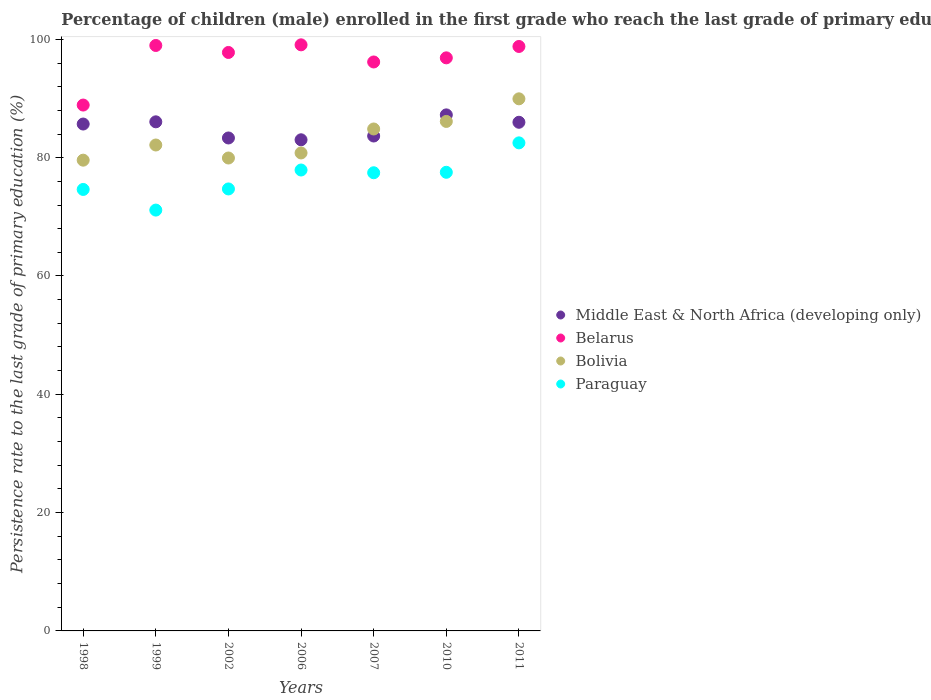How many different coloured dotlines are there?
Ensure brevity in your answer.  4. Is the number of dotlines equal to the number of legend labels?
Your response must be concise. Yes. What is the persistence rate of children in Bolivia in 2002?
Offer a very short reply. 79.95. Across all years, what is the maximum persistence rate of children in Middle East & North Africa (developing only)?
Your answer should be very brief. 87.24. Across all years, what is the minimum persistence rate of children in Paraguay?
Keep it short and to the point. 71.14. In which year was the persistence rate of children in Belarus minimum?
Offer a terse response. 1998. What is the total persistence rate of children in Paraguay in the graph?
Provide a short and direct response. 535.9. What is the difference between the persistence rate of children in Belarus in 1998 and that in 1999?
Give a very brief answer. -10.07. What is the difference between the persistence rate of children in Middle East & North Africa (developing only) in 1998 and the persistence rate of children in Paraguay in 2010?
Your answer should be compact. 8.16. What is the average persistence rate of children in Belarus per year?
Ensure brevity in your answer.  96.66. In the year 2010, what is the difference between the persistence rate of children in Paraguay and persistence rate of children in Bolivia?
Offer a terse response. -8.6. In how many years, is the persistence rate of children in Belarus greater than 8 %?
Offer a terse response. 7. What is the ratio of the persistence rate of children in Middle East & North Africa (developing only) in 2010 to that in 2011?
Your response must be concise. 1.01. Is the persistence rate of children in Bolivia in 1998 less than that in 2010?
Provide a short and direct response. Yes. Is the difference between the persistence rate of children in Paraguay in 2002 and 2010 greater than the difference between the persistence rate of children in Bolivia in 2002 and 2010?
Keep it short and to the point. Yes. What is the difference between the highest and the second highest persistence rate of children in Paraguay?
Provide a short and direct response. 4.59. What is the difference between the highest and the lowest persistence rate of children in Bolivia?
Give a very brief answer. 10.37. Is it the case that in every year, the sum of the persistence rate of children in Bolivia and persistence rate of children in Belarus  is greater than the persistence rate of children in Paraguay?
Offer a very short reply. Yes. What is the difference between two consecutive major ticks on the Y-axis?
Ensure brevity in your answer.  20. Are the values on the major ticks of Y-axis written in scientific E-notation?
Your answer should be compact. No. Does the graph contain any zero values?
Offer a very short reply. No. Where does the legend appear in the graph?
Make the answer very short. Center right. What is the title of the graph?
Ensure brevity in your answer.  Percentage of children (male) enrolled in the first grade who reach the last grade of primary education. What is the label or title of the Y-axis?
Offer a terse response. Persistence rate to the last grade of primary education (%). What is the Persistence rate to the last grade of primary education (%) of Middle East & North Africa (developing only) in 1998?
Make the answer very short. 85.69. What is the Persistence rate to the last grade of primary education (%) of Belarus in 1998?
Offer a terse response. 88.9. What is the Persistence rate to the last grade of primary education (%) in Bolivia in 1998?
Your answer should be very brief. 79.58. What is the Persistence rate to the last grade of primary education (%) in Paraguay in 1998?
Provide a short and direct response. 74.63. What is the Persistence rate to the last grade of primary education (%) in Middle East & North Africa (developing only) in 1999?
Give a very brief answer. 86.06. What is the Persistence rate to the last grade of primary education (%) of Belarus in 1999?
Keep it short and to the point. 98.97. What is the Persistence rate to the last grade of primary education (%) of Bolivia in 1999?
Offer a terse response. 82.15. What is the Persistence rate to the last grade of primary education (%) of Paraguay in 1999?
Ensure brevity in your answer.  71.14. What is the Persistence rate to the last grade of primary education (%) of Middle East & North Africa (developing only) in 2002?
Give a very brief answer. 83.33. What is the Persistence rate to the last grade of primary education (%) of Belarus in 2002?
Make the answer very short. 97.79. What is the Persistence rate to the last grade of primary education (%) of Bolivia in 2002?
Provide a short and direct response. 79.95. What is the Persistence rate to the last grade of primary education (%) of Paraguay in 2002?
Offer a terse response. 74.72. What is the Persistence rate to the last grade of primary education (%) of Middle East & North Africa (developing only) in 2006?
Provide a short and direct response. 83.03. What is the Persistence rate to the last grade of primary education (%) in Belarus in 2006?
Your response must be concise. 99.08. What is the Persistence rate to the last grade of primary education (%) of Bolivia in 2006?
Your response must be concise. 80.8. What is the Persistence rate to the last grade of primary education (%) of Paraguay in 2006?
Provide a short and direct response. 77.92. What is the Persistence rate to the last grade of primary education (%) of Middle East & North Africa (developing only) in 2007?
Make the answer very short. 83.66. What is the Persistence rate to the last grade of primary education (%) of Belarus in 2007?
Offer a very short reply. 96.18. What is the Persistence rate to the last grade of primary education (%) in Bolivia in 2007?
Your answer should be very brief. 84.85. What is the Persistence rate to the last grade of primary education (%) in Paraguay in 2007?
Offer a terse response. 77.45. What is the Persistence rate to the last grade of primary education (%) of Middle East & North Africa (developing only) in 2010?
Your answer should be very brief. 87.24. What is the Persistence rate to the last grade of primary education (%) of Belarus in 2010?
Provide a succinct answer. 96.88. What is the Persistence rate to the last grade of primary education (%) of Bolivia in 2010?
Offer a terse response. 86.13. What is the Persistence rate to the last grade of primary education (%) in Paraguay in 2010?
Give a very brief answer. 77.53. What is the Persistence rate to the last grade of primary education (%) in Middle East & North Africa (developing only) in 2011?
Offer a terse response. 85.99. What is the Persistence rate to the last grade of primary education (%) in Belarus in 2011?
Provide a succinct answer. 98.8. What is the Persistence rate to the last grade of primary education (%) of Bolivia in 2011?
Offer a terse response. 89.95. What is the Persistence rate to the last grade of primary education (%) in Paraguay in 2011?
Offer a very short reply. 82.51. Across all years, what is the maximum Persistence rate to the last grade of primary education (%) of Middle East & North Africa (developing only)?
Provide a short and direct response. 87.24. Across all years, what is the maximum Persistence rate to the last grade of primary education (%) of Belarus?
Keep it short and to the point. 99.08. Across all years, what is the maximum Persistence rate to the last grade of primary education (%) of Bolivia?
Offer a terse response. 89.95. Across all years, what is the maximum Persistence rate to the last grade of primary education (%) of Paraguay?
Your response must be concise. 82.51. Across all years, what is the minimum Persistence rate to the last grade of primary education (%) of Middle East & North Africa (developing only)?
Keep it short and to the point. 83.03. Across all years, what is the minimum Persistence rate to the last grade of primary education (%) of Belarus?
Your answer should be very brief. 88.9. Across all years, what is the minimum Persistence rate to the last grade of primary education (%) in Bolivia?
Your response must be concise. 79.58. Across all years, what is the minimum Persistence rate to the last grade of primary education (%) of Paraguay?
Make the answer very short. 71.14. What is the total Persistence rate to the last grade of primary education (%) in Middle East & North Africa (developing only) in the graph?
Offer a very short reply. 595. What is the total Persistence rate to the last grade of primary education (%) in Belarus in the graph?
Provide a short and direct response. 676.6. What is the total Persistence rate to the last grade of primary education (%) of Bolivia in the graph?
Your answer should be very brief. 583.41. What is the total Persistence rate to the last grade of primary education (%) of Paraguay in the graph?
Your answer should be very brief. 535.9. What is the difference between the Persistence rate to the last grade of primary education (%) in Middle East & North Africa (developing only) in 1998 and that in 1999?
Keep it short and to the point. -0.37. What is the difference between the Persistence rate to the last grade of primary education (%) in Belarus in 1998 and that in 1999?
Your response must be concise. -10.07. What is the difference between the Persistence rate to the last grade of primary education (%) in Bolivia in 1998 and that in 1999?
Provide a succinct answer. -2.56. What is the difference between the Persistence rate to the last grade of primary education (%) of Paraguay in 1998 and that in 1999?
Make the answer very short. 3.49. What is the difference between the Persistence rate to the last grade of primary education (%) in Middle East & North Africa (developing only) in 1998 and that in 2002?
Keep it short and to the point. 2.36. What is the difference between the Persistence rate to the last grade of primary education (%) of Belarus in 1998 and that in 2002?
Make the answer very short. -8.89. What is the difference between the Persistence rate to the last grade of primary education (%) in Bolivia in 1998 and that in 2002?
Make the answer very short. -0.37. What is the difference between the Persistence rate to the last grade of primary education (%) of Paraguay in 1998 and that in 2002?
Keep it short and to the point. -0.09. What is the difference between the Persistence rate to the last grade of primary education (%) of Middle East & North Africa (developing only) in 1998 and that in 2006?
Your answer should be very brief. 2.66. What is the difference between the Persistence rate to the last grade of primary education (%) in Belarus in 1998 and that in 2006?
Your answer should be very brief. -10.18. What is the difference between the Persistence rate to the last grade of primary education (%) of Bolivia in 1998 and that in 2006?
Your answer should be very brief. -1.22. What is the difference between the Persistence rate to the last grade of primary education (%) of Paraguay in 1998 and that in 2006?
Ensure brevity in your answer.  -3.29. What is the difference between the Persistence rate to the last grade of primary education (%) in Middle East & North Africa (developing only) in 1998 and that in 2007?
Your answer should be very brief. 2.02. What is the difference between the Persistence rate to the last grade of primary education (%) in Belarus in 1998 and that in 2007?
Ensure brevity in your answer.  -7.28. What is the difference between the Persistence rate to the last grade of primary education (%) of Bolivia in 1998 and that in 2007?
Provide a succinct answer. -5.27. What is the difference between the Persistence rate to the last grade of primary education (%) in Paraguay in 1998 and that in 2007?
Your answer should be very brief. -2.82. What is the difference between the Persistence rate to the last grade of primary education (%) of Middle East & North Africa (developing only) in 1998 and that in 2010?
Ensure brevity in your answer.  -1.55. What is the difference between the Persistence rate to the last grade of primary education (%) of Belarus in 1998 and that in 2010?
Make the answer very short. -7.98. What is the difference between the Persistence rate to the last grade of primary education (%) of Bolivia in 1998 and that in 2010?
Offer a terse response. -6.55. What is the difference between the Persistence rate to the last grade of primary education (%) in Paraguay in 1998 and that in 2010?
Your answer should be compact. -2.9. What is the difference between the Persistence rate to the last grade of primary education (%) of Middle East & North Africa (developing only) in 1998 and that in 2011?
Provide a succinct answer. -0.3. What is the difference between the Persistence rate to the last grade of primary education (%) of Belarus in 1998 and that in 2011?
Your answer should be compact. -9.9. What is the difference between the Persistence rate to the last grade of primary education (%) of Bolivia in 1998 and that in 2011?
Give a very brief answer. -10.37. What is the difference between the Persistence rate to the last grade of primary education (%) in Paraguay in 1998 and that in 2011?
Your answer should be compact. -7.88. What is the difference between the Persistence rate to the last grade of primary education (%) of Middle East & North Africa (developing only) in 1999 and that in 2002?
Provide a succinct answer. 2.73. What is the difference between the Persistence rate to the last grade of primary education (%) in Belarus in 1999 and that in 2002?
Ensure brevity in your answer.  1.18. What is the difference between the Persistence rate to the last grade of primary education (%) in Bolivia in 1999 and that in 2002?
Keep it short and to the point. 2.2. What is the difference between the Persistence rate to the last grade of primary education (%) in Paraguay in 1999 and that in 2002?
Offer a terse response. -3.57. What is the difference between the Persistence rate to the last grade of primary education (%) of Middle East & North Africa (developing only) in 1999 and that in 2006?
Your answer should be compact. 3.04. What is the difference between the Persistence rate to the last grade of primary education (%) of Belarus in 1999 and that in 2006?
Provide a succinct answer. -0.11. What is the difference between the Persistence rate to the last grade of primary education (%) in Bolivia in 1999 and that in 2006?
Your response must be concise. 1.34. What is the difference between the Persistence rate to the last grade of primary education (%) in Paraguay in 1999 and that in 2006?
Offer a terse response. -6.77. What is the difference between the Persistence rate to the last grade of primary education (%) in Middle East & North Africa (developing only) in 1999 and that in 2007?
Offer a very short reply. 2.4. What is the difference between the Persistence rate to the last grade of primary education (%) in Belarus in 1999 and that in 2007?
Your response must be concise. 2.79. What is the difference between the Persistence rate to the last grade of primary education (%) in Bolivia in 1999 and that in 2007?
Offer a very short reply. -2.71. What is the difference between the Persistence rate to the last grade of primary education (%) in Paraguay in 1999 and that in 2007?
Offer a very short reply. -6.31. What is the difference between the Persistence rate to the last grade of primary education (%) in Middle East & North Africa (developing only) in 1999 and that in 2010?
Offer a very short reply. -1.18. What is the difference between the Persistence rate to the last grade of primary education (%) of Belarus in 1999 and that in 2010?
Provide a succinct answer. 2.09. What is the difference between the Persistence rate to the last grade of primary education (%) of Bolivia in 1999 and that in 2010?
Keep it short and to the point. -3.98. What is the difference between the Persistence rate to the last grade of primary education (%) in Paraguay in 1999 and that in 2010?
Provide a succinct answer. -6.39. What is the difference between the Persistence rate to the last grade of primary education (%) of Middle East & North Africa (developing only) in 1999 and that in 2011?
Make the answer very short. 0.07. What is the difference between the Persistence rate to the last grade of primary education (%) of Belarus in 1999 and that in 2011?
Make the answer very short. 0.17. What is the difference between the Persistence rate to the last grade of primary education (%) of Bolivia in 1999 and that in 2011?
Make the answer very short. -7.81. What is the difference between the Persistence rate to the last grade of primary education (%) in Paraguay in 1999 and that in 2011?
Keep it short and to the point. -11.36. What is the difference between the Persistence rate to the last grade of primary education (%) in Middle East & North Africa (developing only) in 2002 and that in 2006?
Provide a short and direct response. 0.31. What is the difference between the Persistence rate to the last grade of primary education (%) of Belarus in 2002 and that in 2006?
Your answer should be compact. -1.29. What is the difference between the Persistence rate to the last grade of primary education (%) of Bolivia in 2002 and that in 2006?
Ensure brevity in your answer.  -0.85. What is the difference between the Persistence rate to the last grade of primary education (%) of Paraguay in 2002 and that in 2006?
Your response must be concise. -3.2. What is the difference between the Persistence rate to the last grade of primary education (%) of Middle East & North Africa (developing only) in 2002 and that in 2007?
Make the answer very short. -0.33. What is the difference between the Persistence rate to the last grade of primary education (%) of Belarus in 2002 and that in 2007?
Provide a succinct answer. 1.61. What is the difference between the Persistence rate to the last grade of primary education (%) of Bolivia in 2002 and that in 2007?
Your response must be concise. -4.91. What is the difference between the Persistence rate to the last grade of primary education (%) in Paraguay in 2002 and that in 2007?
Provide a succinct answer. -2.74. What is the difference between the Persistence rate to the last grade of primary education (%) in Middle East & North Africa (developing only) in 2002 and that in 2010?
Offer a terse response. -3.9. What is the difference between the Persistence rate to the last grade of primary education (%) in Belarus in 2002 and that in 2010?
Ensure brevity in your answer.  0.91. What is the difference between the Persistence rate to the last grade of primary education (%) of Bolivia in 2002 and that in 2010?
Ensure brevity in your answer.  -6.18. What is the difference between the Persistence rate to the last grade of primary education (%) in Paraguay in 2002 and that in 2010?
Give a very brief answer. -2.82. What is the difference between the Persistence rate to the last grade of primary education (%) of Middle East & North Africa (developing only) in 2002 and that in 2011?
Provide a succinct answer. -2.65. What is the difference between the Persistence rate to the last grade of primary education (%) in Belarus in 2002 and that in 2011?
Keep it short and to the point. -1.01. What is the difference between the Persistence rate to the last grade of primary education (%) of Bolivia in 2002 and that in 2011?
Offer a very short reply. -10. What is the difference between the Persistence rate to the last grade of primary education (%) of Paraguay in 2002 and that in 2011?
Provide a succinct answer. -7.79. What is the difference between the Persistence rate to the last grade of primary education (%) in Middle East & North Africa (developing only) in 2006 and that in 2007?
Offer a very short reply. -0.64. What is the difference between the Persistence rate to the last grade of primary education (%) of Belarus in 2006 and that in 2007?
Your answer should be very brief. 2.9. What is the difference between the Persistence rate to the last grade of primary education (%) of Bolivia in 2006 and that in 2007?
Ensure brevity in your answer.  -4.05. What is the difference between the Persistence rate to the last grade of primary education (%) of Paraguay in 2006 and that in 2007?
Your answer should be very brief. 0.46. What is the difference between the Persistence rate to the last grade of primary education (%) of Middle East & North Africa (developing only) in 2006 and that in 2010?
Keep it short and to the point. -4.21. What is the difference between the Persistence rate to the last grade of primary education (%) of Belarus in 2006 and that in 2010?
Provide a succinct answer. 2.2. What is the difference between the Persistence rate to the last grade of primary education (%) in Bolivia in 2006 and that in 2010?
Your response must be concise. -5.33. What is the difference between the Persistence rate to the last grade of primary education (%) of Paraguay in 2006 and that in 2010?
Your answer should be compact. 0.38. What is the difference between the Persistence rate to the last grade of primary education (%) of Middle East & North Africa (developing only) in 2006 and that in 2011?
Your answer should be very brief. -2.96. What is the difference between the Persistence rate to the last grade of primary education (%) of Belarus in 2006 and that in 2011?
Your answer should be compact. 0.28. What is the difference between the Persistence rate to the last grade of primary education (%) of Bolivia in 2006 and that in 2011?
Give a very brief answer. -9.15. What is the difference between the Persistence rate to the last grade of primary education (%) of Paraguay in 2006 and that in 2011?
Make the answer very short. -4.59. What is the difference between the Persistence rate to the last grade of primary education (%) of Middle East & North Africa (developing only) in 2007 and that in 2010?
Offer a very short reply. -3.57. What is the difference between the Persistence rate to the last grade of primary education (%) in Belarus in 2007 and that in 2010?
Provide a short and direct response. -0.7. What is the difference between the Persistence rate to the last grade of primary education (%) of Bolivia in 2007 and that in 2010?
Provide a succinct answer. -1.28. What is the difference between the Persistence rate to the last grade of primary education (%) of Paraguay in 2007 and that in 2010?
Provide a short and direct response. -0.08. What is the difference between the Persistence rate to the last grade of primary education (%) in Middle East & North Africa (developing only) in 2007 and that in 2011?
Offer a terse response. -2.32. What is the difference between the Persistence rate to the last grade of primary education (%) of Belarus in 2007 and that in 2011?
Your answer should be very brief. -2.62. What is the difference between the Persistence rate to the last grade of primary education (%) in Bolivia in 2007 and that in 2011?
Your response must be concise. -5.1. What is the difference between the Persistence rate to the last grade of primary education (%) in Paraguay in 2007 and that in 2011?
Provide a succinct answer. -5.05. What is the difference between the Persistence rate to the last grade of primary education (%) in Middle East & North Africa (developing only) in 2010 and that in 2011?
Keep it short and to the point. 1.25. What is the difference between the Persistence rate to the last grade of primary education (%) in Belarus in 2010 and that in 2011?
Ensure brevity in your answer.  -1.92. What is the difference between the Persistence rate to the last grade of primary education (%) of Bolivia in 2010 and that in 2011?
Keep it short and to the point. -3.82. What is the difference between the Persistence rate to the last grade of primary education (%) of Paraguay in 2010 and that in 2011?
Offer a very short reply. -4.97. What is the difference between the Persistence rate to the last grade of primary education (%) in Middle East & North Africa (developing only) in 1998 and the Persistence rate to the last grade of primary education (%) in Belarus in 1999?
Provide a short and direct response. -13.28. What is the difference between the Persistence rate to the last grade of primary education (%) in Middle East & North Africa (developing only) in 1998 and the Persistence rate to the last grade of primary education (%) in Bolivia in 1999?
Ensure brevity in your answer.  3.54. What is the difference between the Persistence rate to the last grade of primary education (%) in Middle East & North Africa (developing only) in 1998 and the Persistence rate to the last grade of primary education (%) in Paraguay in 1999?
Your answer should be compact. 14.55. What is the difference between the Persistence rate to the last grade of primary education (%) in Belarus in 1998 and the Persistence rate to the last grade of primary education (%) in Bolivia in 1999?
Offer a terse response. 6.75. What is the difference between the Persistence rate to the last grade of primary education (%) of Belarus in 1998 and the Persistence rate to the last grade of primary education (%) of Paraguay in 1999?
Make the answer very short. 17.76. What is the difference between the Persistence rate to the last grade of primary education (%) in Bolivia in 1998 and the Persistence rate to the last grade of primary education (%) in Paraguay in 1999?
Keep it short and to the point. 8.44. What is the difference between the Persistence rate to the last grade of primary education (%) in Middle East & North Africa (developing only) in 1998 and the Persistence rate to the last grade of primary education (%) in Belarus in 2002?
Your answer should be compact. -12.1. What is the difference between the Persistence rate to the last grade of primary education (%) of Middle East & North Africa (developing only) in 1998 and the Persistence rate to the last grade of primary education (%) of Bolivia in 2002?
Your answer should be compact. 5.74. What is the difference between the Persistence rate to the last grade of primary education (%) in Middle East & North Africa (developing only) in 1998 and the Persistence rate to the last grade of primary education (%) in Paraguay in 2002?
Keep it short and to the point. 10.97. What is the difference between the Persistence rate to the last grade of primary education (%) of Belarus in 1998 and the Persistence rate to the last grade of primary education (%) of Bolivia in 2002?
Keep it short and to the point. 8.95. What is the difference between the Persistence rate to the last grade of primary education (%) of Belarus in 1998 and the Persistence rate to the last grade of primary education (%) of Paraguay in 2002?
Your answer should be compact. 14.18. What is the difference between the Persistence rate to the last grade of primary education (%) in Bolivia in 1998 and the Persistence rate to the last grade of primary education (%) in Paraguay in 2002?
Ensure brevity in your answer.  4.86. What is the difference between the Persistence rate to the last grade of primary education (%) in Middle East & North Africa (developing only) in 1998 and the Persistence rate to the last grade of primary education (%) in Belarus in 2006?
Keep it short and to the point. -13.39. What is the difference between the Persistence rate to the last grade of primary education (%) in Middle East & North Africa (developing only) in 1998 and the Persistence rate to the last grade of primary education (%) in Bolivia in 2006?
Offer a very short reply. 4.89. What is the difference between the Persistence rate to the last grade of primary education (%) of Middle East & North Africa (developing only) in 1998 and the Persistence rate to the last grade of primary education (%) of Paraguay in 2006?
Offer a terse response. 7.77. What is the difference between the Persistence rate to the last grade of primary education (%) of Belarus in 1998 and the Persistence rate to the last grade of primary education (%) of Bolivia in 2006?
Make the answer very short. 8.1. What is the difference between the Persistence rate to the last grade of primary education (%) in Belarus in 1998 and the Persistence rate to the last grade of primary education (%) in Paraguay in 2006?
Give a very brief answer. 10.98. What is the difference between the Persistence rate to the last grade of primary education (%) of Bolivia in 1998 and the Persistence rate to the last grade of primary education (%) of Paraguay in 2006?
Offer a very short reply. 1.66. What is the difference between the Persistence rate to the last grade of primary education (%) in Middle East & North Africa (developing only) in 1998 and the Persistence rate to the last grade of primary education (%) in Belarus in 2007?
Offer a very short reply. -10.49. What is the difference between the Persistence rate to the last grade of primary education (%) of Middle East & North Africa (developing only) in 1998 and the Persistence rate to the last grade of primary education (%) of Bolivia in 2007?
Provide a short and direct response. 0.84. What is the difference between the Persistence rate to the last grade of primary education (%) of Middle East & North Africa (developing only) in 1998 and the Persistence rate to the last grade of primary education (%) of Paraguay in 2007?
Provide a short and direct response. 8.24. What is the difference between the Persistence rate to the last grade of primary education (%) in Belarus in 1998 and the Persistence rate to the last grade of primary education (%) in Bolivia in 2007?
Your answer should be compact. 4.05. What is the difference between the Persistence rate to the last grade of primary education (%) in Belarus in 1998 and the Persistence rate to the last grade of primary education (%) in Paraguay in 2007?
Your answer should be very brief. 11.45. What is the difference between the Persistence rate to the last grade of primary education (%) in Bolivia in 1998 and the Persistence rate to the last grade of primary education (%) in Paraguay in 2007?
Ensure brevity in your answer.  2.13. What is the difference between the Persistence rate to the last grade of primary education (%) in Middle East & North Africa (developing only) in 1998 and the Persistence rate to the last grade of primary education (%) in Belarus in 2010?
Offer a very short reply. -11.19. What is the difference between the Persistence rate to the last grade of primary education (%) of Middle East & North Africa (developing only) in 1998 and the Persistence rate to the last grade of primary education (%) of Bolivia in 2010?
Give a very brief answer. -0.44. What is the difference between the Persistence rate to the last grade of primary education (%) in Middle East & North Africa (developing only) in 1998 and the Persistence rate to the last grade of primary education (%) in Paraguay in 2010?
Your answer should be compact. 8.16. What is the difference between the Persistence rate to the last grade of primary education (%) in Belarus in 1998 and the Persistence rate to the last grade of primary education (%) in Bolivia in 2010?
Keep it short and to the point. 2.77. What is the difference between the Persistence rate to the last grade of primary education (%) in Belarus in 1998 and the Persistence rate to the last grade of primary education (%) in Paraguay in 2010?
Keep it short and to the point. 11.37. What is the difference between the Persistence rate to the last grade of primary education (%) in Bolivia in 1998 and the Persistence rate to the last grade of primary education (%) in Paraguay in 2010?
Your answer should be compact. 2.05. What is the difference between the Persistence rate to the last grade of primary education (%) in Middle East & North Africa (developing only) in 1998 and the Persistence rate to the last grade of primary education (%) in Belarus in 2011?
Offer a terse response. -13.11. What is the difference between the Persistence rate to the last grade of primary education (%) in Middle East & North Africa (developing only) in 1998 and the Persistence rate to the last grade of primary education (%) in Bolivia in 2011?
Your answer should be compact. -4.26. What is the difference between the Persistence rate to the last grade of primary education (%) in Middle East & North Africa (developing only) in 1998 and the Persistence rate to the last grade of primary education (%) in Paraguay in 2011?
Your answer should be compact. 3.18. What is the difference between the Persistence rate to the last grade of primary education (%) of Belarus in 1998 and the Persistence rate to the last grade of primary education (%) of Bolivia in 2011?
Keep it short and to the point. -1.05. What is the difference between the Persistence rate to the last grade of primary education (%) in Belarus in 1998 and the Persistence rate to the last grade of primary education (%) in Paraguay in 2011?
Your response must be concise. 6.39. What is the difference between the Persistence rate to the last grade of primary education (%) in Bolivia in 1998 and the Persistence rate to the last grade of primary education (%) in Paraguay in 2011?
Keep it short and to the point. -2.93. What is the difference between the Persistence rate to the last grade of primary education (%) in Middle East & North Africa (developing only) in 1999 and the Persistence rate to the last grade of primary education (%) in Belarus in 2002?
Your answer should be very brief. -11.73. What is the difference between the Persistence rate to the last grade of primary education (%) of Middle East & North Africa (developing only) in 1999 and the Persistence rate to the last grade of primary education (%) of Bolivia in 2002?
Offer a very short reply. 6.12. What is the difference between the Persistence rate to the last grade of primary education (%) in Middle East & North Africa (developing only) in 1999 and the Persistence rate to the last grade of primary education (%) in Paraguay in 2002?
Offer a terse response. 11.35. What is the difference between the Persistence rate to the last grade of primary education (%) of Belarus in 1999 and the Persistence rate to the last grade of primary education (%) of Bolivia in 2002?
Offer a terse response. 19.02. What is the difference between the Persistence rate to the last grade of primary education (%) of Belarus in 1999 and the Persistence rate to the last grade of primary education (%) of Paraguay in 2002?
Your answer should be compact. 24.25. What is the difference between the Persistence rate to the last grade of primary education (%) of Bolivia in 1999 and the Persistence rate to the last grade of primary education (%) of Paraguay in 2002?
Give a very brief answer. 7.43. What is the difference between the Persistence rate to the last grade of primary education (%) in Middle East & North Africa (developing only) in 1999 and the Persistence rate to the last grade of primary education (%) in Belarus in 2006?
Provide a short and direct response. -13.02. What is the difference between the Persistence rate to the last grade of primary education (%) of Middle East & North Africa (developing only) in 1999 and the Persistence rate to the last grade of primary education (%) of Bolivia in 2006?
Make the answer very short. 5.26. What is the difference between the Persistence rate to the last grade of primary education (%) in Middle East & North Africa (developing only) in 1999 and the Persistence rate to the last grade of primary education (%) in Paraguay in 2006?
Your answer should be compact. 8.15. What is the difference between the Persistence rate to the last grade of primary education (%) in Belarus in 1999 and the Persistence rate to the last grade of primary education (%) in Bolivia in 2006?
Provide a succinct answer. 18.17. What is the difference between the Persistence rate to the last grade of primary education (%) of Belarus in 1999 and the Persistence rate to the last grade of primary education (%) of Paraguay in 2006?
Provide a short and direct response. 21.05. What is the difference between the Persistence rate to the last grade of primary education (%) of Bolivia in 1999 and the Persistence rate to the last grade of primary education (%) of Paraguay in 2006?
Offer a terse response. 4.23. What is the difference between the Persistence rate to the last grade of primary education (%) of Middle East & North Africa (developing only) in 1999 and the Persistence rate to the last grade of primary education (%) of Belarus in 2007?
Provide a short and direct response. -10.12. What is the difference between the Persistence rate to the last grade of primary education (%) of Middle East & North Africa (developing only) in 1999 and the Persistence rate to the last grade of primary education (%) of Bolivia in 2007?
Make the answer very short. 1.21. What is the difference between the Persistence rate to the last grade of primary education (%) of Middle East & North Africa (developing only) in 1999 and the Persistence rate to the last grade of primary education (%) of Paraguay in 2007?
Offer a terse response. 8.61. What is the difference between the Persistence rate to the last grade of primary education (%) of Belarus in 1999 and the Persistence rate to the last grade of primary education (%) of Bolivia in 2007?
Keep it short and to the point. 14.12. What is the difference between the Persistence rate to the last grade of primary education (%) in Belarus in 1999 and the Persistence rate to the last grade of primary education (%) in Paraguay in 2007?
Provide a succinct answer. 21.52. What is the difference between the Persistence rate to the last grade of primary education (%) in Bolivia in 1999 and the Persistence rate to the last grade of primary education (%) in Paraguay in 2007?
Make the answer very short. 4.69. What is the difference between the Persistence rate to the last grade of primary education (%) of Middle East & North Africa (developing only) in 1999 and the Persistence rate to the last grade of primary education (%) of Belarus in 2010?
Keep it short and to the point. -10.82. What is the difference between the Persistence rate to the last grade of primary education (%) in Middle East & North Africa (developing only) in 1999 and the Persistence rate to the last grade of primary education (%) in Bolivia in 2010?
Your answer should be compact. -0.07. What is the difference between the Persistence rate to the last grade of primary education (%) of Middle East & North Africa (developing only) in 1999 and the Persistence rate to the last grade of primary education (%) of Paraguay in 2010?
Provide a short and direct response. 8.53. What is the difference between the Persistence rate to the last grade of primary education (%) of Belarus in 1999 and the Persistence rate to the last grade of primary education (%) of Bolivia in 2010?
Your response must be concise. 12.84. What is the difference between the Persistence rate to the last grade of primary education (%) in Belarus in 1999 and the Persistence rate to the last grade of primary education (%) in Paraguay in 2010?
Your answer should be very brief. 21.44. What is the difference between the Persistence rate to the last grade of primary education (%) in Bolivia in 1999 and the Persistence rate to the last grade of primary education (%) in Paraguay in 2010?
Provide a succinct answer. 4.61. What is the difference between the Persistence rate to the last grade of primary education (%) of Middle East & North Africa (developing only) in 1999 and the Persistence rate to the last grade of primary education (%) of Belarus in 2011?
Offer a very short reply. -12.74. What is the difference between the Persistence rate to the last grade of primary education (%) in Middle East & North Africa (developing only) in 1999 and the Persistence rate to the last grade of primary education (%) in Bolivia in 2011?
Offer a terse response. -3.89. What is the difference between the Persistence rate to the last grade of primary education (%) of Middle East & North Africa (developing only) in 1999 and the Persistence rate to the last grade of primary education (%) of Paraguay in 2011?
Your answer should be very brief. 3.56. What is the difference between the Persistence rate to the last grade of primary education (%) in Belarus in 1999 and the Persistence rate to the last grade of primary education (%) in Bolivia in 2011?
Your answer should be very brief. 9.02. What is the difference between the Persistence rate to the last grade of primary education (%) in Belarus in 1999 and the Persistence rate to the last grade of primary education (%) in Paraguay in 2011?
Make the answer very short. 16.46. What is the difference between the Persistence rate to the last grade of primary education (%) of Bolivia in 1999 and the Persistence rate to the last grade of primary education (%) of Paraguay in 2011?
Provide a short and direct response. -0.36. What is the difference between the Persistence rate to the last grade of primary education (%) in Middle East & North Africa (developing only) in 2002 and the Persistence rate to the last grade of primary education (%) in Belarus in 2006?
Provide a succinct answer. -15.74. What is the difference between the Persistence rate to the last grade of primary education (%) in Middle East & North Africa (developing only) in 2002 and the Persistence rate to the last grade of primary education (%) in Bolivia in 2006?
Your answer should be very brief. 2.53. What is the difference between the Persistence rate to the last grade of primary education (%) of Middle East & North Africa (developing only) in 2002 and the Persistence rate to the last grade of primary education (%) of Paraguay in 2006?
Offer a terse response. 5.42. What is the difference between the Persistence rate to the last grade of primary education (%) of Belarus in 2002 and the Persistence rate to the last grade of primary education (%) of Bolivia in 2006?
Ensure brevity in your answer.  16.99. What is the difference between the Persistence rate to the last grade of primary education (%) of Belarus in 2002 and the Persistence rate to the last grade of primary education (%) of Paraguay in 2006?
Your response must be concise. 19.87. What is the difference between the Persistence rate to the last grade of primary education (%) in Bolivia in 2002 and the Persistence rate to the last grade of primary education (%) in Paraguay in 2006?
Provide a succinct answer. 2.03. What is the difference between the Persistence rate to the last grade of primary education (%) of Middle East & North Africa (developing only) in 2002 and the Persistence rate to the last grade of primary education (%) of Belarus in 2007?
Your answer should be compact. -12.85. What is the difference between the Persistence rate to the last grade of primary education (%) of Middle East & North Africa (developing only) in 2002 and the Persistence rate to the last grade of primary education (%) of Bolivia in 2007?
Your response must be concise. -1.52. What is the difference between the Persistence rate to the last grade of primary education (%) in Middle East & North Africa (developing only) in 2002 and the Persistence rate to the last grade of primary education (%) in Paraguay in 2007?
Provide a short and direct response. 5.88. What is the difference between the Persistence rate to the last grade of primary education (%) of Belarus in 2002 and the Persistence rate to the last grade of primary education (%) of Bolivia in 2007?
Offer a very short reply. 12.94. What is the difference between the Persistence rate to the last grade of primary education (%) in Belarus in 2002 and the Persistence rate to the last grade of primary education (%) in Paraguay in 2007?
Ensure brevity in your answer.  20.34. What is the difference between the Persistence rate to the last grade of primary education (%) of Bolivia in 2002 and the Persistence rate to the last grade of primary education (%) of Paraguay in 2007?
Keep it short and to the point. 2.49. What is the difference between the Persistence rate to the last grade of primary education (%) of Middle East & North Africa (developing only) in 2002 and the Persistence rate to the last grade of primary education (%) of Belarus in 2010?
Your answer should be compact. -13.54. What is the difference between the Persistence rate to the last grade of primary education (%) of Middle East & North Africa (developing only) in 2002 and the Persistence rate to the last grade of primary education (%) of Bolivia in 2010?
Keep it short and to the point. -2.8. What is the difference between the Persistence rate to the last grade of primary education (%) of Middle East & North Africa (developing only) in 2002 and the Persistence rate to the last grade of primary education (%) of Paraguay in 2010?
Provide a succinct answer. 5.8. What is the difference between the Persistence rate to the last grade of primary education (%) of Belarus in 2002 and the Persistence rate to the last grade of primary education (%) of Bolivia in 2010?
Your response must be concise. 11.66. What is the difference between the Persistence rate to the last grade of primary education (%) of Belarus in 2002 and the Persistence rate to the last grade of primary education (%) of Paraguay in 2010?
Give a very brief answer. 20.26. What is the difference between the Persistence rate to the last grade of primary education (%) of Bolivia in 2002 and the Persistence rate to the last grade of primary education (%) of Paraguay in 2010?
Offer a terse response. 2.42. What is the difference between the Persistence rate to the last grade of primary education (%) of Middle East & North Africa (developing only) in 2002 and the Persistence rate to the last grade of primary education (%) of Belarus in 2011?
Your answer should be very brief. -15.47. What is the difference between the Persistence rate to the last grade of primary education (%) of Middle East & North Africa (developing only) in 2002 and the Persistence rate to the last grade of primary education (%) of Bolivia in 2011?
Your response must be concise. -6.62. What is the difference between the Persistence rate to the last grade of primary education (%) of Middle East & North Africa (developing only) in 2002 and the Persistence rate to the last grade of primary education (%) of Paraguay in 2011?
Your answer should be compact. 0.83. What is the difference between the Persistence rate to the last grade of primary education (%) in Belarus in 2002 and the Persistence rate to the last grade of primary education (%) in Bolivia in 2011?
Your answer should be very brief. 7.84. What is the difference between the Persistence rate to the last grade of primary education (%) of Belarus in 2002 and the Persistence rate to the last grade of primary education (%) of Paraguay in 2011?
Offer a terse response. 15.28. What is the difference between the Persistence rate to the last grade of primary education (%) of Bolivia in 2002 and the Persistence rate to the last grade of primary education (%) of Paraguay in 2011?
Make the answer very short. -2.56. What is the difference between the Persistence rate to the last grade of primary education (%) of Middle East & North Africa (developing only) in 2006 and the Persistence rate to the last grade of primary education (%) of Belarus in 2007?
Offer a terse response. -13.16. What is the difference between the Persistence rate to the last grade of primary education (%) of Middle East & North Africa (developing only) in 2006 and the Persistence rate to the last grade of primary education (%) of Bolivia in 2007?
Ensure brevity in your answer.  -1.83. What is the difference between the Persistence rate to the last grade of primary education (%) of Middle East & North Africa (developing only) in 2006 and the Persistence rate to the last grade of primary education (%) of Paraguay in 2007?
Provide a succinct answer. 5.57. What is the difference between the Persistence rate to the last grade of primary education (%) in Belarus in 2006 and the Persistence rate to the last grade of primary education (%) in Bolivia in 2007?
Provide a short and direct response. 14.22. What is the difference between the Persistence rate to the last grade of primary education (%) in Belarus in 2006 and the Persistence rate to the last grade of primary education (%) in Paraguay in 2007?
Your answer should be compact. 21.63. What is the difference between the Persistence rate to the last grade of primary education (%) in Bolivia in 2006 and the Persistence rate to the last grade of primary education (%) in Paraguay in 2007?
Your response must be concise. 3.35. What is the difference between the Persistence rate to the last grade of primary education (%) in Middle East & North Africa (developing only) in 2006 and the Persistence rate to the last grade of primary education (%) in Belarus in 2010?
Your answer should be compact. -13.85. What is the difference between the Persistence rate to the last grade of primary education (%) of Middle East & North Africa (developing only) in 2006 and the Persistence rate to the last grade of primary education (%) of Bolivia in 2010?
Offer a very short reply. -3.1. What is the difference between the Persistence rate to the last grade of primary education (%) in Middle East & North Africa (developing only) in 2006 and the Persistence rate to the last grade of primary education (%) in Paraguay in 2010?
Give a very brief answer. 5.49. What is the difference between the Persistence rate to the last grade of primary education (%) of Belarus in 2006 and the Persistence rate to the last grade of primary education (%) of Bolivia in 2010?
Your response must be concise. 12.95. What is the difference between the Persistence rate to the last grade of primary education (%) in Belarus in 2006 and the Persistence rate to the last grade of primary education (%) in Paraguay in 2010?
Keep it short and to the point. 21.55. What is the difference between the Persistence rate to the last grade of primary education (%) in Bolivia in 2006 and the Persistence rate to the last grade of primary education (%) in Paraguay in 2010?
Your answer should be very brief. 3.27. What is the difference between the Persistence rate to the last grade of primary education (%) in Middle East & North Africa (developing only) in 2006 and the Persistence rate to the last grade of primary education (%) in Belarus in 2011?
Ensure brevity in your answer.  -15.78. What is the difference between the Persistence rate to the last grade of primary education (%) in Middle East & North Africa (developing only) in 2006 and the Persistence rate to the last grade of primary education (%) in Bolivia in 2011?
Your answer should be compact. -6.93. What is the difference between the Persistence rate to the last grade of primary education (%) in Middle East & North Africa (developing only) in 2006 and the Persistence rate to the last grade of primary education (%) in Paraguay in 2011?
Provide a succinct answer. 0.52. What is the difference between the Persistence rate to the last grade of primary education (%) in Belarus in 2006 and the Persistence rate to the last grade of primary education (%) in Bolivia in 2011?
Your answer should be compact. 9.13. What is the difference between the Persistence rate to the last grade of primary education (%) of Belarus in 2006 and the Persistence rate to the last grade of primary education (%) of Paraguay in 2011?
Keep it short and to the point. 16.57. What is the difference between the Persistence rate to the last grade of primary education (%) of Bolivia in 2006 and the Persistence rate to the last grade of primary education (%) of Paraguay in 2011?
Your response must be concise. -1.7. What is the difference between the Persistence rate to the last grade of primary education (%) in Middle East & North Africa (developing only) in 2007 and the Persistence rate to the last grade of primary education (%) in Belarus in 2010?
Offer a very short reply. -13.21. What is the difference between the Persistence rate to the last grade of primary education (%) in Middle East & North Africa (developing only) in 2007 and the Persistence rate to the last grade of primary education (%) in Bolivia in 2010?
Your answer should be compact. -2.46. What is the difference between the Persistence rate to the last grade of primary education (%) of Middle East & North Africa (developing only) in 2007 and the Persistence rate to the last grade of primary education (%) of Paraguay in 2010?
Your answer should be very brief. 6.13. What is the difference between the Persistence rate to the last grade of primary education (%) of Belarus in 2007 and the Persistence rate to the last grade of primary education (%) of Bolivia in 2010?
Keep it short and to the point. 10.05. What is the difference between the Persistence rate to the last grade of primary education (%) in Belarus in 2007 and the Persistence rate to the last grade of primary education (%) in Paraguay in 2010?
Your response must be concise. 18.65. What is the difference between the Persistence rate to the last grade of primary education (%) of Bolivia in 2007 and the Persistence rate to the last grade of primary education (%) of Paraguay in 2010?
Ensure brevity in your answer.  7.32. What is the difference between the Persistence rate to the last grade of primary education (%) in Middle East & North Africa (developing only) in 2007 and the Persistence rate to the last grade of primary education (%) in Belarus in 2011?
Provide a short and direct response. -15.14. What is the difference between the Persistence rate to the last grade of primary education (%) in Middle East & North Africa (developing only) in 2007 and the Persistence rate to the last grade of primary education (%) in Bolivia in 2011?
Give a very brief answer. -6.29. What is the difference between the Persistence rate to the last grade of primary education (%) in Middle East & North Africa (developing only) in 2007 and the Persistence rate to the last grade of primary education (%) in Paraguay in 2011?
Your response must be concise. 1.16. What is the difference between the Persistence rate to the last grade of primary education (%) of Belarus in 2007 and the Persistence rate to the last grade of primary education (%) of Bolivia in 2011?
Offer a terse response. 6.23. What is the difference between the Persistence rate to the last grade of primary education (%) in Belarus in 2007 and the Persistence rate to the last grade of primary education (%) in Paraguay in 2011?
Your answer should be compact. 13.67. What is the difference between the Persistence rate to the last grade of primary education (%) of Bolivia in 2007 and the Persistence rate to the last grade of primary education (%) of Paraguay in 2011?
Your answer should be very brief. 2.35. What is the difference between the Persistence rate to the last grade of primary education (%) of Middle East & North Africa (developing only) in 2010 and the Persistence rate to the last grade of primary education (%) of Belarus in 2011?
Ensure brevity in your answer.  -11.56. What is the difference between the Persistence rate to the last grade of primary education (%) in Middle East & North Africa (developing only) in 2010 and the Persistence rate to the last grade of primary education (%) in Bolivia in 2011?
Ensure brevity in your answer.  -2.71. What is the difference between the Persistence rate to the last grade of primary education (%) of Middle East & North Africa (developing only) in 2010 and the Persistence rate to the last grade of primary education (%) of Paraguay in 2011?
Provide a short and direct response. 4.73. What is the difference between the Persistence rate to the last grade of primary education (%) in Belarus in 2010 and the Persistence rate to the last grade of primary education (%) in Bolivia in 2011?
Offer a very short reply. 6.93. What is the difference between the Persistence rate to the last grade of primary education (%) of Belarus in 2010 and the Persistence rate to the last grade of primary education (%) of Paraguay in 2011?
Give a very brief answer. 14.37. What is the difference between the Persistence rate to the last grade of primary education (%) of Bolivia in 2010 and the Persistence rate to the last grade of primary education (%) of Paraguay in 2011?
Offer a very short reply. 3.62. What is the average Persistence rate to the last grade of primary education (%) in Middle East & North Africa (developing only) per year?
Make the answer very short. 85. What is the average Persistence rate to the last grade of primary education (%) in Belarus per year?
Provide a short and direct response. 96.66. What is the average Persistence rate to the last grade of primary education (%) in Bolivia per year?
Your answer should be very brief. 83.34. What is the average Persistence rate to the last grade of primary education (%) of Paraguay per year?
Offer a terse response. 76.56. In the year 1998, what is the difference between the Persistence rate to the last grade of primary education (%) of Middle East & North Africa (developing only) and Persistence rate to the last grade of primary education (%) of Belarus?
Provide a short and direct response. -3.21. In the year 1998, what is the difference between the Persistence rate to the last grade of primary education (%) of Middle East & North Africa (developing only) and Persistence rate to the last grade of primary education (%) of Bolivia?
Offer a very short reply. 6.11. In the year 1998, what is the difference between the Persistence rate to the last grade of primary education (%) of Middle East & North Africa (developing only) and Persistence rate to the last grade of primary education (%) of Paraguay?
Make the answer very short. 11.06. In the year 1998, what is the difference between the Persistence rate to the last grade of primary education (%) of Belarus and Persistence rate to the last grade of primary education (%) of Bolivia?
Provide a short and direct response. 9.32. In the year 1998, what is the difference between the Persistence rate to the last grade of primary education (%) of Belarus and Persistence rate to the last grade of primary education (%) of Paraguay?
Offer a very short reply. 14.27. In the year 1998, what is the difference between the Persistence rate to the last grade of primary education (%) in Bolivia and Persistence rate to the last grade of primary education (%) in Paraguay?
Your response must be concise. 4.95. In the year 1999, what is the difference between the Persistence rate to the last grade of primary education (%) of Middle East & North Africa (developing only) and Persistence rate to the last grade of primary education (%) of Belarus?
Offer a very short reply. -12.91. In the year 1999, what is the difference between the Persistence rate to the last grade of primary education (%) of Middle East & North Africa (developing only) and Persistence rate to the last grade of primary education (%) of Bolivia?
Offer a very short reply. 3.92. In the year 1999, what is the difference between the Persistence rate to the last grade of primary education (%) of Middle East & North Africa (developing only) and Persistence rate to the last grade of primary education (%) of Paraguay?
Your response must be concise. 14.92. In the year 1999, what is the difference between the Persistence rate to the last grade of primary education (%) in Belarus and Persistence rate to the last grade of primary education (%) in Bolivia?
Provide a succinct answer. 16.83. In the year 1999, what is the difference between the Persistence rate to the last grade of primary education (%) of Belarus and Persistence rate to the last grade of primary education (%) of Paraguay?
Provide a succinct answer. 27.83. In the year 1999, what is the difference between the Persistence rate to the last grade of primary education (%) in Bolivia and Persistence rate to the last grade of primary education (%) in Paraguay?
Give a very brief answer. 11. In the year 2002, what is the difference between the Persistence rate to the last grade of primary education (%) of Middle East & North Africa (developing only) and Persistence rate to the last grade of primary education (%) of Belarus?
Your answer should be compact. -14.45. In the year 2002, what is the difference between the Persistence rate to the last grade of primary education (%) of Middle East & North Africa (developing only) and Persistence rate to the last grade of primary education (%) of Bolivia?
Keep it short and to the point. 3.39. In the year 2002, what is the difference between the Persistence rate to the last grade of primary education (%) of Middle East & North Africa (developing only) and Persistence rate to the last grade of primary education (%) of Paraguay?
Offer a terse response. 8.62. In the year 2002, what is the difference between the Persistence rate to the last grade of primary education (%) in Belarus and Persistence rate to the last grade of primary education (%) in Bolivia?
Keep it short and to the point. 17.84. In the year 2002, what is the difference between the Persistence rate to the last grade of primary education (%) of Belarus and Persistence rate to the last grade of primary education (%) of Paraguay?
Your answer should be very brief. 23.07. In the year 2002, what is the difference between the Persistence rate to the last grade of primary education (%) in Bolivia and Persistence rate to the last grade of primary education (%) in Paraguay?
Offer a very short reply. 5.23. In the year 2006, what is the difference between the Persistence rate to the last grade of primary education (%) in Middle East & North Africa (developing only) and Persistence rate to the last grade of primary education (%) in Belarus?
Your response must be concise. -16.05. In the year 2006, what is the difference between the Persistence rate to the last grade of primary education (%) of Middle East & North Africa (developing only) and Persistence rate to the last grade of primary education (%) of Bolivia?
Offer a terse response. 2.22. In the year 2006, what is the difference between the Persistence rate to the last grade of primary education (%) of Middle East & North Africa (developing only) and Persistence rate to the last grade of primary education (%) of Paraguay?
Your answer should be very brief. 5.11. In the year 2006, what is the difference between the Persistence rate to the last grade of primary education (%) in Belarus and Persistence rate to the last grade of primary education (%) in Bolivia?
Offer a very short reply. 18.28. In the year 2006, what is the difference between the Persistence rate to the last grade of primary education (%) of Belarus and Persistence rate to the last grade of primary education (%) of Paraguay?
Provide a succinct answer. 21.16. In the year 2006, what is the difference between the Persistence rate to the last grade of primary education (%) in Bolivia and Persistence rate to the last grade of primary education (%) in Paraguay?
Provide a short and direct response. 2.89. In the year 2007, what is the difference between the Persistence rate to the last grade of primary education (%) of Middle East & North Africa (developing only) and Persistence rate to the last grade of primary education (%) of Belarus?
Your response must be concise. -12.52. In the year 2007, what is the difference between the Persistence rate to the last grade of primary education (%) of Middle East & North Africa (developing only) and Persistence rate to the last grade of primary education (%) of Bolivia?
Offer a very short reply. -1.19. In the year 2007, what is the difference between the Persistence rate to the last grade of primary education (%) in Middle East & North Africa (developing only) and Persistence rate to the last grade of primary education (%) in Paraguay?
Your response must be concise. 6.21. In the year 2007, what is the difference between the Persistence rate to the last grade of primary education (%) of Belarus and Persistence rate to the last grade of primary education (%) of Bolivia?
Provide a succinct answer. 11.33. In the year 2007, what is the difference between the Persistence rate to the last grade of primary education (%) of Belarus and Persistence rate to the last grade of primary education (%) of Paraguay?
Give a very brief answer. 18.73. In the year 2007, what is the difference between the Persistence rate to the last grade of primary education (%) in Bolivia and Persistence rate to the last grade of primary education (%) in Paraguay?
Make the answer very short. 7.4. In the year 2010, what is the difference between the Persistence rate to the last grade of primary education (%) of Middle East & North Africa (developing only) and Persistence rate to the last grade of primary education (%) of Belarus?
Give a very brief answer. -9.64. In the year 2010, what is the difference between the Persistence rate to the last grade of primary education (%) in Middle East & North Africa (developing only) and Persistence rate to the last grade of primary education (%) in Bolivia?
Offer a very short reply. 1.11. In the year 2010, what is the difference between the Persistence rate to the last grade of primary education (%) in Middle East & North Africa (developing only) and Persistence rate to the last grade of primary education (%) in Paraguay?
Offer a very short reply. 9.71. In the year 2010, what is the difference between the Persistence rate to the last grade of primary education (%) in Belarus and Persistence rate to the last grade of primary education (%) in Bolivia?
Offer a terse response. 10.75. In the year 2010, what is the difference between the Persistence rate to the last grade of primary education (%) in Belarus and Persistence rate to the last grade of primary education (%) in Paraguay?
Offer a terse response. 19.35. In the year 2010, what is the difference between the Persistence rate to the last grade of primary education (%) in Bolivia and Persistence rate to the last grade of primary education (%) in Paraguay?
Provide a short and direct response. 8.6. In the year 2011, what is the difference between the Persistence rate to the last grade of primary education (%) of Middle East & North Africa (developing only) and Persistence rate to the last grade of primary education (%) of Belarus?
Your answer should be compact. -12.81. In the year 2011, what is the difference between the Persistence rate to the last grade of primary education (%) of Middle East & North Africa (developing only) and Persistence rate to the last grade of primary education (%) of Bolivia?
Keep it short and to the point. -3.96. In the year 2011, what is the difference between the Persistence rate to the last grade of primary education (%) of Middle East & North Africa (developing only) and Persistence rate to the last grade of primary education (%) of Paraguay?
Offer a very short reply. 3.48. In the year 2011, what is the difference between the Persistence rate to the last grade of primary education (%) of Belarus and Persistence rate to the last grade of primary education (%) of Bolivia?
Make the answer very short. 8.85. In the year 2011, what is the difference between the Persistence rate to the last grade of primary education (%) in Belarus and Persistence rate to the last grade of primary education (%) in Paraguay?
Provide a short and direct response. 16.3. In the year 2011, what is the difference between the Persistence rate to the last grade of primary education (%) in Bolivia and Persistence rate to the last grade of primary education (%) in Paraguay?
Offer a very short reply. 7.44. What is the ratio of the Persistence rate to the last grade of primary education (%) of Belarus in 1998 to that in 1999?
Make the answer very short. 0.9. What is the ratio of the Persistence rate to the last grade of primary education (%) in Bolivia in 1998 to that in 1999?
Your answer should be compact. 0.97. What is the ratio of the Persistence rate to the last grade of primary education (%) of Paraguay in 1998 to that in 1999?
Keep it short and to the point. 1.05. What is the ratio of the Persistence rate to the last grade of primary education (%) of Middle East & North Africa (developing only) in 1998 to that in 2002?
Provide a short and direct response. 1.03. What is the ratio of the Persistence rate to the last grade of primary education (%) in Belarus in 1998 to that in 2002?
Your answer should be compact. 0.91. What is the ratio of the Persistence rate to the last grade of primary education (%) in Bolivia in 1998 to that in 2002?
Your answer should be compact. 1. What is the ratio of the Persistence rate to the last grade of primary education (%) of Paraguay in 1998 to that in 2002?
Offer a very short reply. 1. What is the ratio of the Persistence rate to the last grade of primary education (%) in Middle East & North Africa (developing only) in 1998 to that in 2006?
Your answer should be compact. 1.03. What is the ratio of the Persistence rate to the last grade of primary education (%) in Belarus in 1998 to that in 2006?
Ensure brevity in your answer.  0.9. What is the ratio of the Persistence rate to the last grade of primary education (%) of Bolivia in 1998 to that in 2006?
Provide a short and direct response. 0.98. What is the ratio of the Persistence rate to the last grade of primary education (%) in Paraguay in 1998 to that in 2006?
Provide a short and direct response. 0.96. What is the ratio of the Persistence rate to the last grade of primary education (%) of Middle East & North Africa (developing only) in 1998 to that in 2007?
Give a very brief answer. 1.02. What is the ratio of the Persistence rate to the last grade of primary education (%) of Belarus in 1998 to that in 2007?
Keep it short and to the point. 0.92. What is the ratio of the Persistence rate to the last grade of primary education (%) in Bolivia in 1998 to that in 2007?
Offer a very short reply. 0.94. What is the ratio of the Persistence rate to the last grade of primary education (%) in Paraguay in 1998 to that in 2007?
Provide a short and direct response. 0.96. What is the ratio of the Persistence rate to the last grade of primary education (%) in Middle East & North Africa (developing only) in 1998 to that in 2010?
Offer a very short reply. 0.98. What is the ratio of the Persistence rate to the last grade of primary education (%) in Belarus in 1998 to that in 2010?
Make the answer very short. 0.92. What is the ratio of the Persistence rate to the last grade of primary education (%) in Bolivia in 1998 to that in 2010?
Provide a succinct answer. 0.92. What is the ratio of the Persistence rate to the last grade of primary education (%) of Paraguay in 1998 to that in 2010?
Offer a very short reply. 0.96. What is the ratio of the Persistence rate to the last grade of primary education (%) in Middle East & North Africa (developing only) in 1998 to that in 2011?
Your answer should be compact. 1. What is the ratio of the Persistence rate to the last grade of primary education (%) in Belarus in 1998 to that in 2011?
Keep it short and to the point. 0.9. What is the ratio of the Persistence rate to the last grade of primary education (%) of Bolivia in 1998 to that in 2011?
Offer a terse response. 0.88. What is the ratio of the Persistence rate to the last grade of primary education (%) of Paraguay in 1998 to that in 2011?
Offer a terse response. 0.9. What is the ratio of the Persistence rate to the last grade of primary education (%) in Middle East & North Africa (developing only) in 1999 to that in 2002?
Your answer should be very brief. 1.03. What is the ratio of the Persistence rate to the last grade of primary education (%) in Belarus in 1999 to that in 2002?
Offer a very short reply. 1.01. What is the ratio of the Persistence rate to the last grade of primary education (%) in Bolivia in 1999 to that in 2002?
Your answer should be compact. 1.03. What is the ratio of the Persistence rate to the last grade of primary education (%) in Paraguay in 1999 to that in 2002?
Keep it short and to the point. 0.95. What is the ratio of the Persistence rate to the last grade of primary education (%) of Middle East & North Africa (developing only) in 1999 to that in 2006?
Your answer should be compact. 1.04. What is the ratio of the Persistence rate to the last grade of primary education (%) of Bolivia in 1999 to that in 2006?
Your answer should be very brief. 1.02. What is the ratio of the Persistence rate to the last grade of primary education (%) in Paraguay in 1999 to that in 2006?
Ensure brevity in your answer.  0.91. What is the ratio of the Persistence rate to the last grade of primary education (%) in Middle East & North Africa (developing only) in 1999 to that in 2007?
Offer a very short reply. 1.03. What is the ratio of the Persistence rate to the last grade of primary education (%) of Belarus in 1999 to that in 2007?
Provide a succinct answer. 1.03. What is the ratio of the Persistence rate to the last grade of primary education (%) in Bolivia in 1999 to that in 2007?
Offer a very short reply. 0.97. What is the ratio of the Persistence rate to the last grade of primary education (%) of Paraguay in 1999 to that in 2007?
Your answer should be very brief. 0.92. What is the ratio of the Persistence rate to the last grade of primary education (%) of Middle East & North Africa (developing only) in 1999 to that in 2010?
Provide a succinct answer. 0.99. What is the ratio of the Persistence rate to the last grade of primary education (%) of Belarus in 1999 to that in 2010?
Ensure brevity in your answer.  1.02. What is the ratio of the Persistence rate to the last grade of primary education (%) in Bolivia in 1999 to that in 2010?
Your response must be concise. 0.95. What is the ratio of the Persistence rate to the last grade of primary education (%) of Paraguay in 1999 to that in 2010?
Keep it short and to the point. 0.92. What is the ratio of the Persistence rate to the last grade of primary education (%) in Middle East & North Africa (developing only) in 1999 to that in 2011?
Ensure brevity in your answer.  1. What is the ratio of the Persistence rate to the last grade of primary education (%) in Belarus in 1999 to that in 2011?
Make the answer very short. 1. What is the ratio of the Persistence rate to the last grade of primary education (%) of Bolivia in 1999 to that in 2011?
Offer a very short reply. 0.91. What is the ratio of the Persistence rate to the last grade of primary education (%) in Paraguay in 1999 to that in 2011?
Offer a very short reply. 0.86. What is the ratio of the Persistence rate to the last grade of primary education (%) of Middle East & North Africa (developing only) in 2002 to that in 2006?
Provide a succinct answer. 1. What is the ratio of the Persistence rate to the last grade of primary education (%) in Belarus in 2002 to that in 2006?
Your answer should be compact. 0.99. What is the ratio of the Persistence rate to the last grade of primary education (%) of Bolivia in 2002 to that in 2006?
Your answer should be compact. 0.99. What is the ratio of the Persistence rate to the last grade of primary education (%) of Paraguay in 2002 to that in 2006?
Your response must be concise. 0.96. What is the ratio of the Persistence rate to the last grade of primary education (%) in Belarus in 2002 to that in 2007?
Keep it short and to the point. 1.02. What is the ratio of the Persistence rate to the last grade of primary education (%) of Bolivia in 2002 to that in 2007?
Provide a succinct answer. 0.94. What is the ratio of the Persistence rate to the last grade of primary education (%) of Paraguay in 2002 to that in 2007?
Keep it short and to the point. 0.96. What is the ratio of the Persistence rate to the last grade of primary education (%) in Middle East & North Africa (developing only) in 2002 to that in 2010?
Give a very brief answer. 0.96. What is the ratio of the Persistence rate to the last grade of primary education (%) in Belarus in 2002 to that in 2010?
Make the answer very short. 1.01. What is the ratio of the Persistence rate to the last grade of primary education (%) in Bolivia in 2002 to that in 2010?
Your response must be concise. 0.93. What is the ratio of the Persistence rate to the last grade of primary education (%) in Paraguay in 2002 to that in 2010?
Keep it short and to the point. 0.96. What is the ratio of the Persistence rate to the last grade of primary education (%) of Middle East & North Africa (developing only) in 2002 to that in 2011?
Keep it short and to the point. 0.97. What is the ratio of the Persistence rate to the last grade of primary education (%) in Bolivia in 2002 to that in 2011?
Offer a very short reply. 0.89. What is the ratio of the Persistence rate to the last grade of primary education (%) of Paraguay in 2002 to that in 2011?
Give a very brief answer. 0.91. What is the ratio of the Persistence rate to the last grade of primary education (%) of Middle East & North Africa (developing only) in 2006 to that in 2007?
Keep it short and to the point. 0.99. What is the ratio of the Persistence rate to the last grade of primary education (%) of Belarus in 2006 to that in 2007?
Offer a terse response. 1.03. What is the ratio of the Persistence rate to the last grade of primary education (%) of Bolivia in 2006 to that in 2007?
Provide a succinct answer. 0.95. What is the ratio of the Persistence rate to the last grade of primary education (%) in Middle East & North Africa (developing only) in 2006 to that in 2010?
Make the answer very short. 0.95. What is the ratio of the Persistence rate to the last grade of primary education (%) of Belarus in 2006 to that in 2010?
Offer a very short reply. 1.02. What is the ratio of the Persistence rate to the last grade of primary education (%) of Bolivia in 2006 to that in 2010?
Provide a succinct answer. 0.94. What is the ratio of the Persistence rate to the last grade of primary education (%) of Middle East & North Africa (developing only) in 2006 to that in 2011?
Your answer should be compact. 0.97. What is the ratio of the Persistence rate to the last grade of primary education (%) of Belarus in 2006 to that in 2011?
Ensure brevity in your answer.  1. What is the ratio of the Persistence rate to the last grade of primary education (%) in Bolivia in 2006 to that in 2011?
Provide a short and direct response. 0.9. What is the ratio of the Persistence rate to the last grade of primary education (%) of Paraguay in 2006 to that in 2011?
Keep it short and to the point. 0.94. What is the ratio of the Persistence rate to the last grade of primary education (%) of Belarus in 2007 to that in 2010?
Your response must be concise. 0.99. What is the ratio of the Persistence rate to the last grade of primary education (%) of Bolivia in 2007 to that in 2010?
Offer a terse response. 0.99. What is the ratio of the Persistence rate to the last grade of primary education (%) in Middle East & North Africa (developing only) in 2007 to that in 2011?
Keep it short and to the point. 0.97. What is the ratio of the Persistence rate to the last grade of primary education (%) in Belarus in 2007 to that in 2011?
Your response must be concise. 0.97. What is the ratio of the Persistence rate to the last grade of primary education (%) in Bolivia in 2007 to that in 2011?
Your answer should be compact. 0.94. What is the ratio of the Persistence rate to the last grade of primary education (%) of Paraguay in 2007 to that in 2011?
Your answer should be very brief. 0.94. What is the ratio of the Persistence rate to the last grade of primary education (%) of Middle East & North Africa (developing only) in 2010 to that in 2011?
Your answer should be very brief. 1.01. What is the ratio of the Persistence rate to the last grade of primary education (%) of Belarus in 2010 to that in 2011?
Offer a terse response. 0.98. What is the ratio of the Persistence rate to the last grade of primary education (%) in Bolivia in 2010 to that in 2011?
Your answer should be very brief. 0.96. What is the ratio of the Persistence rate to the last grade of primary education (%) of Paraguay in 2010 to that in 2011?
Make the answer very short. 0.94. What is the difference between the highest and the second highest Persistence rate to the last grade of primary education (%) in Middle East & North Africa (developing only)?
Give a very brief answer. 1.18. What is the difference between the highest and the second highest Persistence rate to the last grade of primary education (%) in Belarus?
Give a very brief answer. 0.11. What is the difference between the highest and the second highest Persistence rate to the last grade of primary education (%) in Bolivia?
Offer a very short reply. 3.82. What is the difference between the highest and the second highest Persistence rate to the last grade of primary education (%) in Paraguay?
Provide a short and direct response. 4.59. What is the difference between the highest and the lowest Persistence rate to the last grade of primary education (%) of Middle East & North Africa (developing only)?
Provide a short and direct response. 4.21. What is the difference between the highest and the lowest Persistence rate to the last grade of primary education (%) of Belarus?
Offer a very short reply. 10.18. What is the difference between the highest and the lowest Persistence rate to the last grade of primary education (%) of Bolivia?
Your answer should be compact. 10.37. What is the difference between the highest and the lowest Persistence rate to the last grade of primary education (%) in Paraguay?
Give a very brief answer. 11.36. 